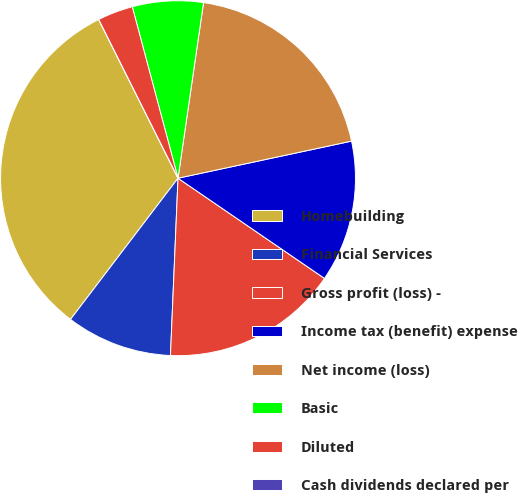Convert chart. <chart><loc_0><loc_0><loc_500><loc_500><pie_chart><fcel>Homebuilding<fcel>Financial Services<fcel>Gross profit (loss) -<fcel>Income tax (benefit) expense<fcel>Net income (loss)<fcel>Basic<fcel>Diluted<fcel>Cash dividends declared per<nl><fcel>32.26%<fcel>9.68%<fcel>16.13%<fcel>12.9%<fcel>19.35%<fcel>6.45%<fcel>3.23%<fcel>0.0%<nl></chart> 